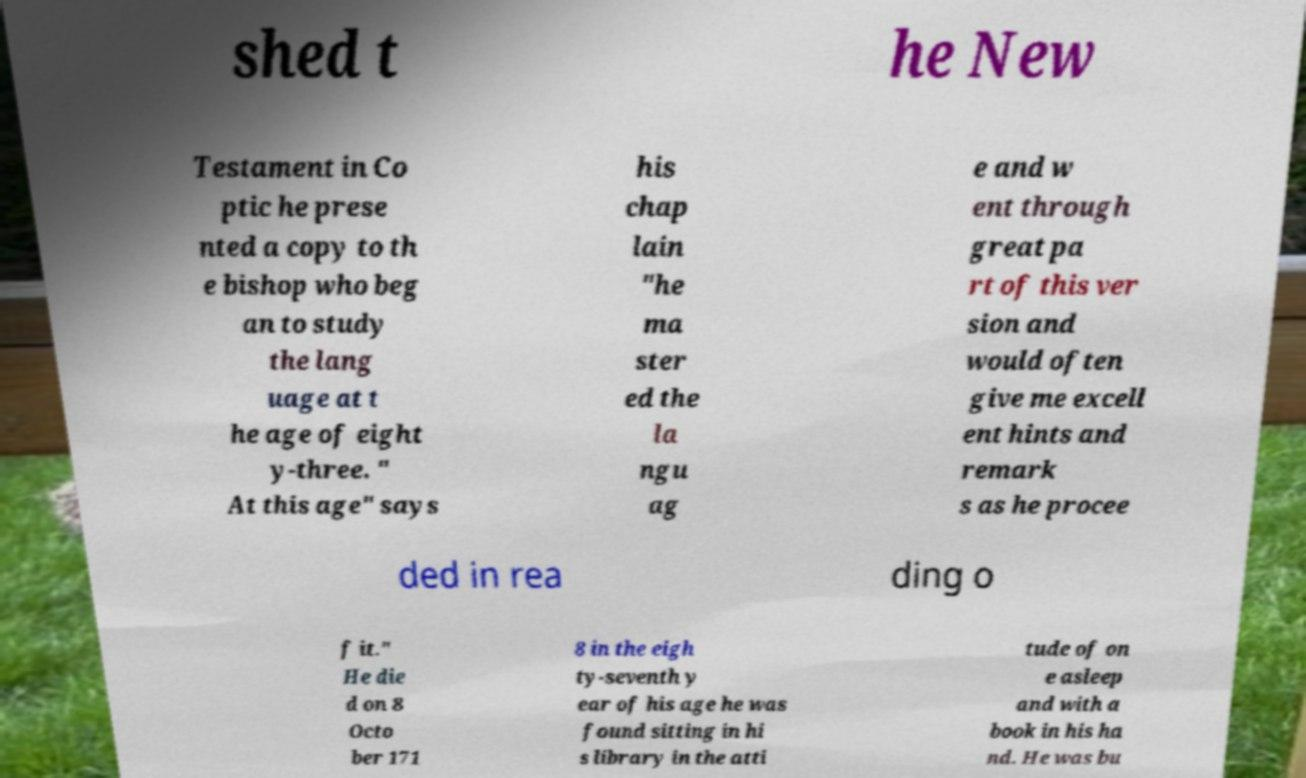I need the written content from this picture converted into text. Can you do that? shed t he New Testament in Co ptic he prese nted a copy to th e bishop who beg an to study the lang uage at t he age of eight y-three. " At this age" says his chap lain "he ma ster ed the la ngu ag e and w ent through great pa rt of this ver sion and would often give me excell ent hints and remark s as he procee ded in rea ding o f it." He die d on 8 Octo ber 171 8 in the eigh ty-seventh y ear of his age he was found sitting in hi s library in the atti tude of on e asleep and with a book in his ha nd. He was bu 